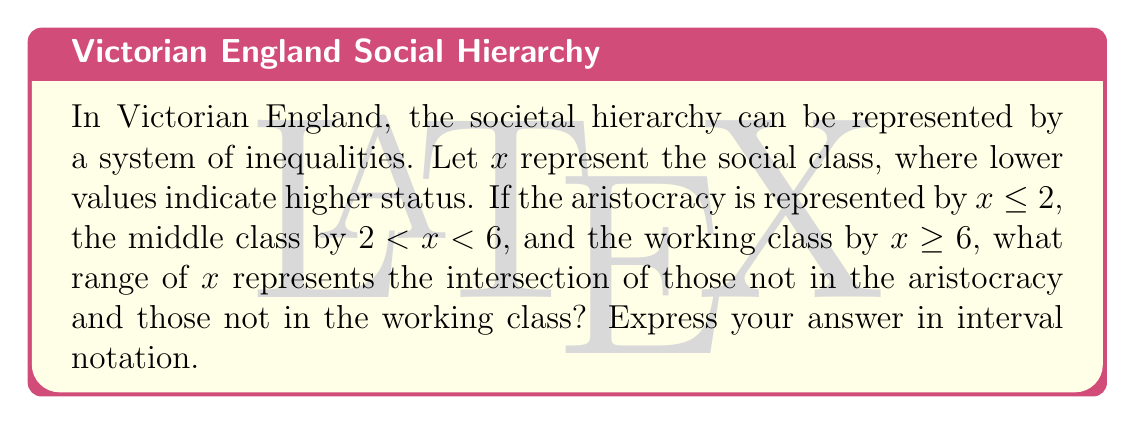Solve this math problem. To solve this problem, we need to follow these steps:

1) First, let's identify the given inequalities:
   Aristocracy: $x \leq 2$
   Middle class: $2 < x < 6$
   Working class: $x \geq 6$

2) We need to find those who are not in the aristocracy AND not in the working class.
   Not in aristocracy: $x > 2$
   Not in working class: $x < 6$

3) Combining these conditions:
   $2 < x < 6$

4) This inequality represents the middle class, which is logical as they are neither aristocracy nor working class.

5) To express this in interval notation, we use parentheses to indicate open endpoints:
   $(2, 6)$

This result invites philosophical reflection on the nature of social stratification in Victorian England. The clear mathematical boundaries between classes mirror the rigid social divisions of the era, yet the continuous nature of the number line might suggest a more fluid reality beneath the surface of these societal constructs.
Answer: $(2, 6)$ 